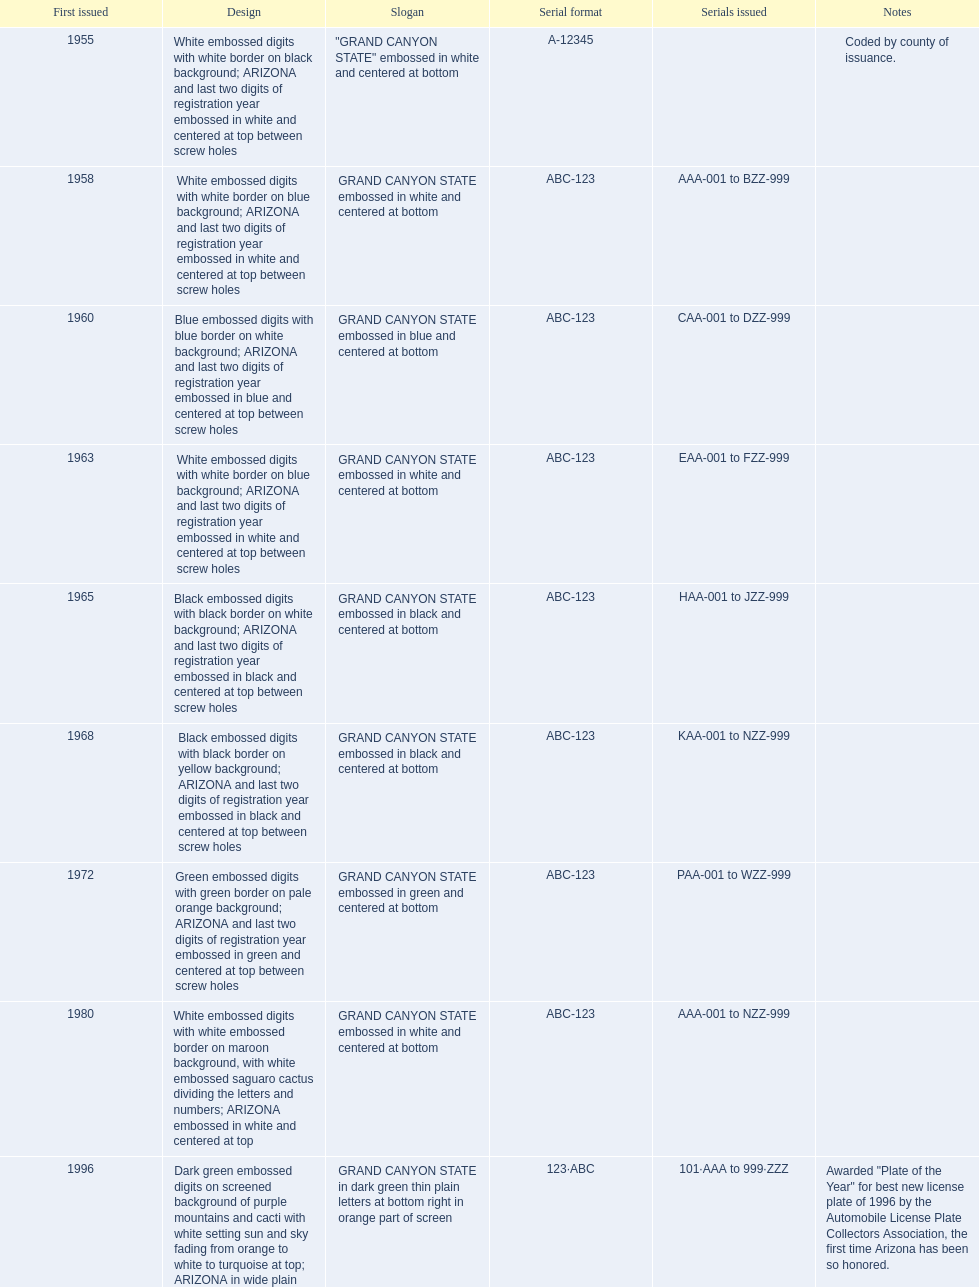What is the average serial format of the arizona license plates? ABC-123. 